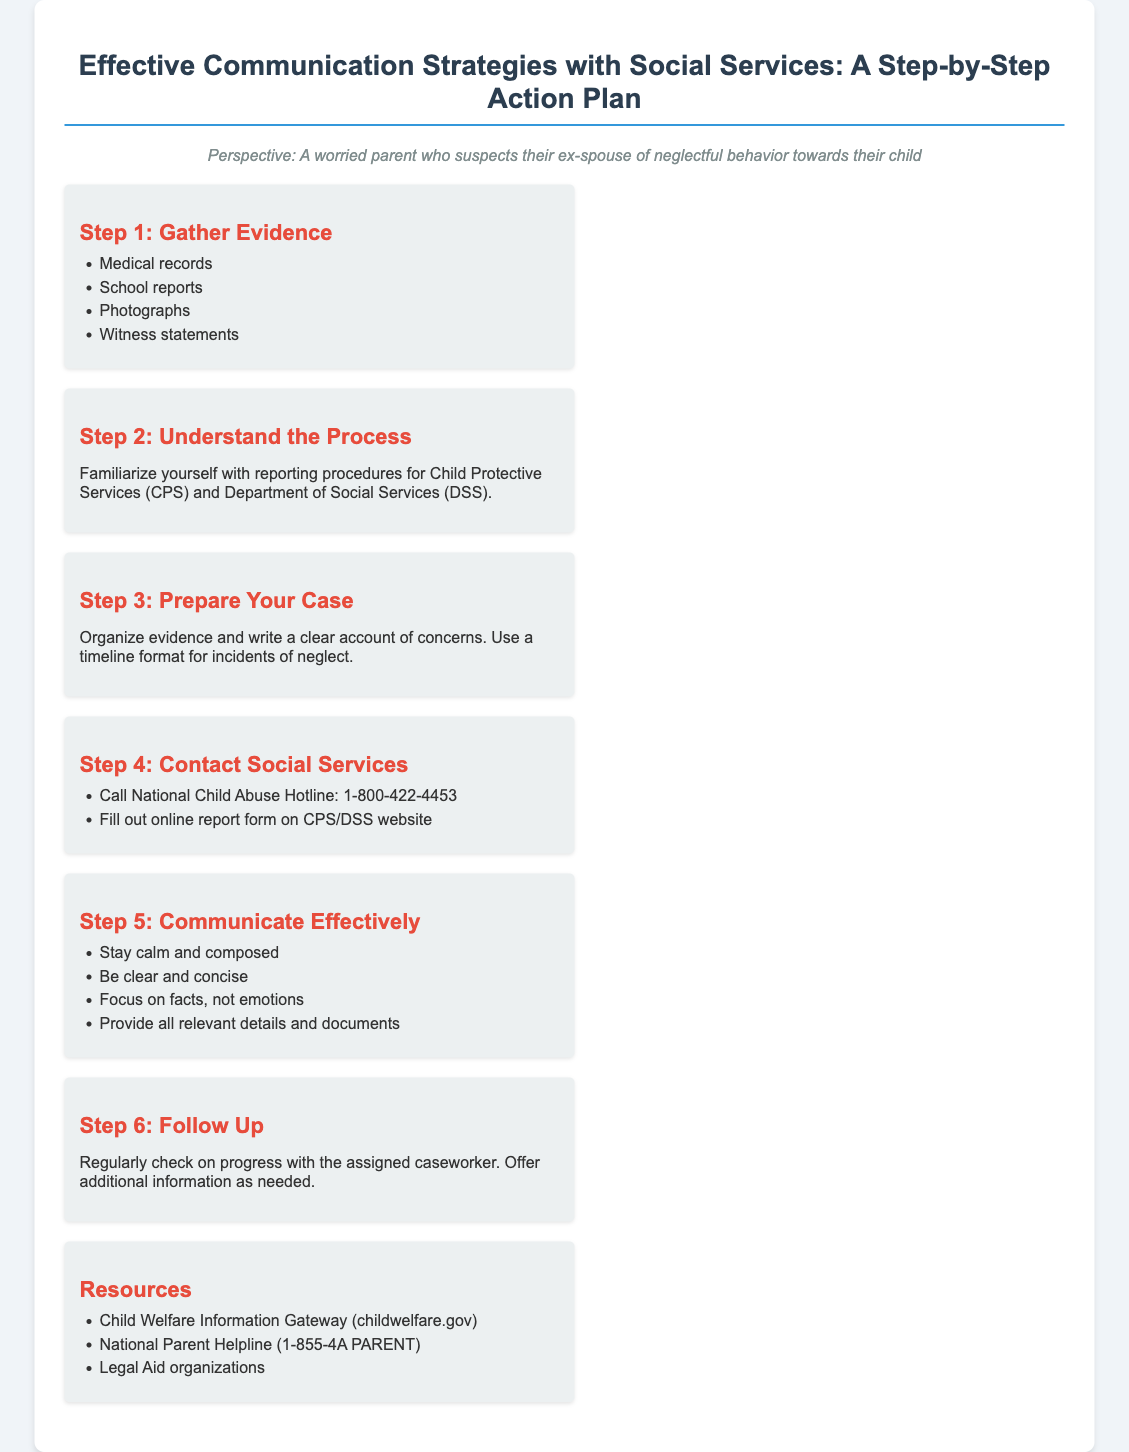What is the first step in the action plan? The first step listed in the action plan is to gather evidence, which includes medical records and school reports.
Answer: Gather Evidence What hotline should you call for child abuse concerns? The document specifies calling the National Child Abuse Hotline for reporting concerns.
Answer: 1-800-422-4453 How many steps are outlined in the action plan? The document lists a total of six steps in the action plan.
Answer: Six What should you do to prepare your case? To prepare your case, you should organize evidence and write a clear account of concerns using a timeline format.
Answer: Organize evidence What is one resource listed for parents? One resource mentioned for parents is the Child Welfare Information Gateway.
Answer: Child Welfare Information Gateway What is the purpose of the follow-up step? The follow-up step is intended to regularly check on progress with the assigned caseworker.
Answer: Check on progress What is emphasized in Step 5 regarding communication? Step 5 emphasizes that communication should be calm and composed, focusing on facts.
Answer: Stay calm and composed What type of documents is suggested to provide? The document suggests providing all relevant details and documents during communication with social services.
Answer: Relevant details and documents 